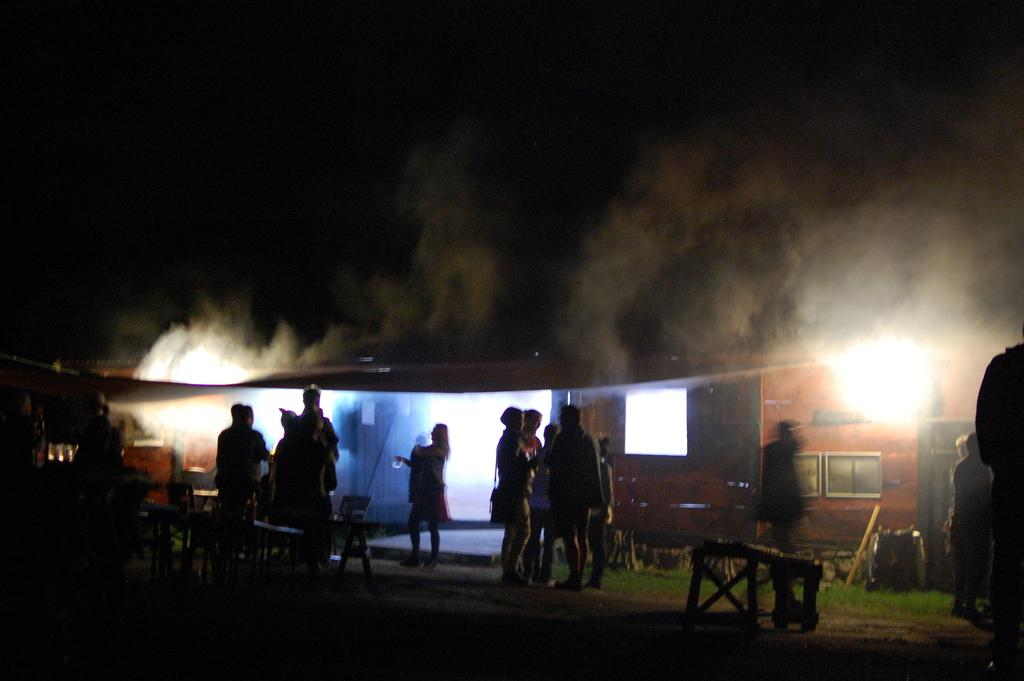What type of furniture can be seen in the image? There are tables in the image. What are the people in the image doing? There are groups of people standing in the image. What else can be seen in the image besides tables and people? There are other objects in the image. What type of building is depicted in the image? The image appears to depict a house. What is the condition of the background in the image? The background of the image is dark. Can you describe any visible effects in the image? There is smoke visible in the image. What type of print can be seen on the people's clothing in the image? There is no information about the people's clothing in the image, so it is impossible to determine if there is any print. What type of drink is being served at the house in the image? There is no indication of any drinks being served in the image. 